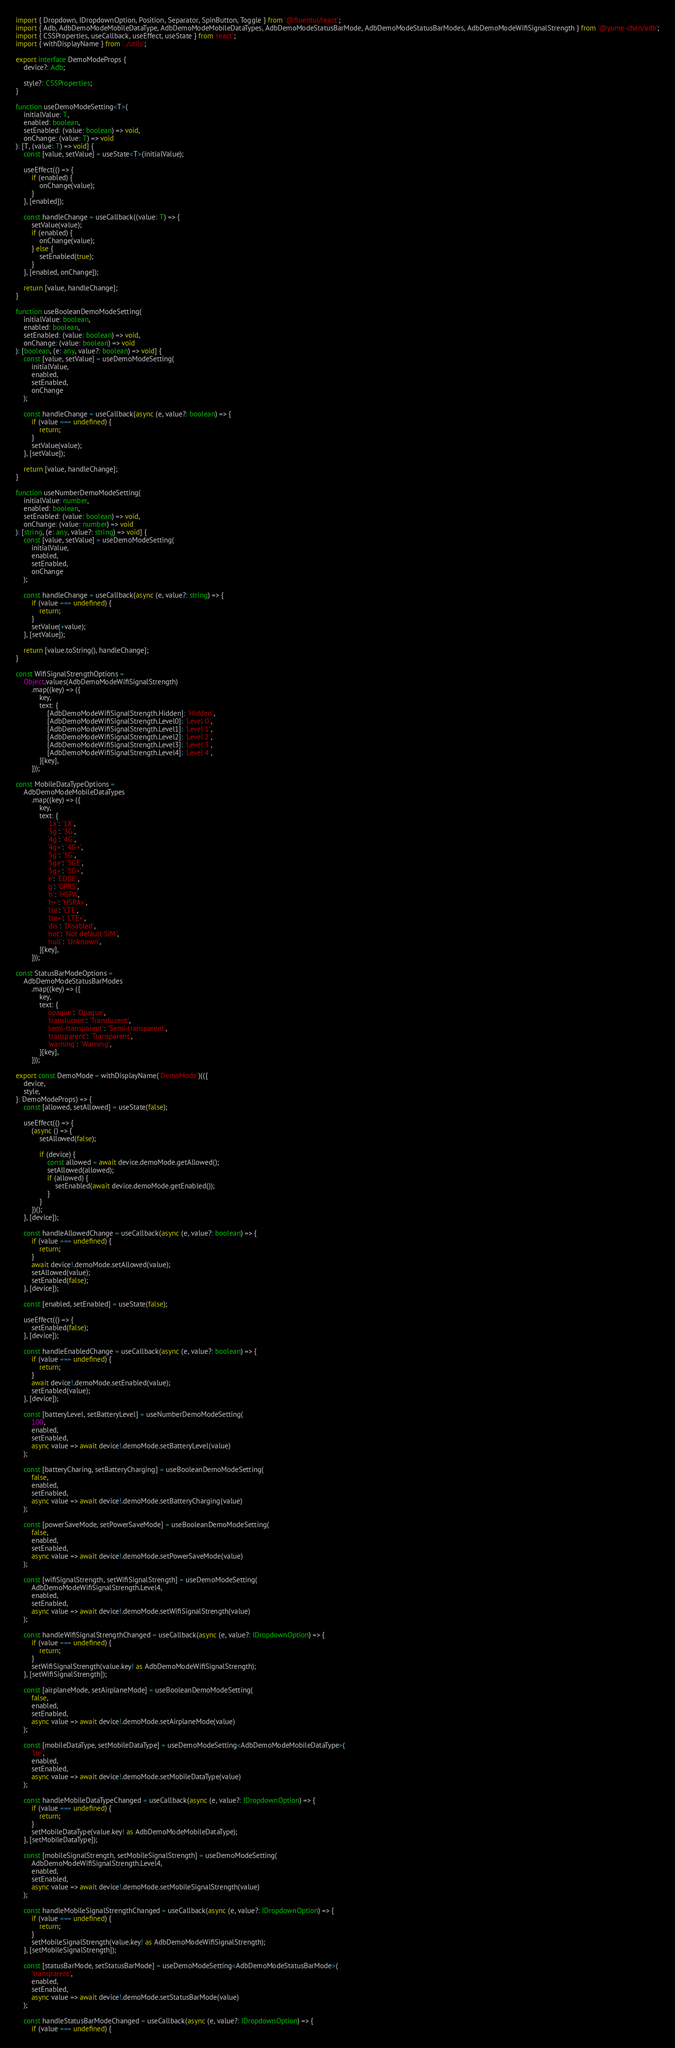<code> <loc_0><loc_0><loc_500><loc_500><_TypeScript_>import { Dropdown, IDropdownOption, Position, Separator, SpinButton, Toggle } from '@fluentui/react';
import { Adb, AdbDemoModeMobileDataType, AdbDemoModeMobileDataTypes, AdbDemoModeStatusBarMode, AdbDemoModeStatusBarModes, AdbDemoModeWifiSignalStrength } from '@yume-chan/adb';
import { CSSProperties, useCallback, useEffect, useState } from 'react';
import { withDisplayName } from '../utils';

export interface DemoModeProps {
    device?: Adb;

    style?: CSSProperties;
}

function useDemoModeSetting<T>(
    initialValue: T,
    enabled: boolean,
    setEnabled: (value: boolean) => void,
    onChange: (value: T) => void
): [T, (value: T) => void] {
    const [value, setValue] = useState<T>(initialValue);

    useEffect(() => {
        if (enabled) {
            onChange(value);
        }
    }, [enabled]);

    const handleChange = useCallback((value: T) => {
        setValue(value);
        if (enabled) {
            onChange(value);
        } else {
            setEnabled(true);
        }
    }, [enabled, onChange]);

    return [value, handleChange];
}

function useBooleanDemoModeSetting(
    initialValue: boolean,
    enabled: boolean,
    setEnabled: (value: boolean) => void,
    onChange: (value: boolean) => void
): [boolean, (e: any, value?: boolean) => void] {
    const [value, setValue] = useDemoModeSetting(
        initialValue,
        enabled,
        setEnabled,
        onChange
    );

    const handleChange = useCallback(async (e, value?: boolean) => {
        if (value === undefined) {
            return;
        }
        setValue(value);
    }, [setValue]);

    return [value, handleChange];
}

function useNumberDemoModeSetting(
    initialValue: number,
    enabled: boolean,
    setEnabled: (value: boolean) => void,
    onChange: (value: number) => void
): [string, (e: any, value?: string) => void] {
    const [value, setValue] = useDemoModeSetting(
        initialValue,
        enabled,
        setEnabled,
        onChange
    );

    const handleChange = useCallback(async (e, value?: string) => {
        if (value === undefined) {
            return;
        }
        setValue(+value);
    }, [setValue]);

    return [value.toString(), handleChange];
}

const WifiSignalStrengthOptions =
    Object.values(AdbDemoModeWifiSignalStrength)
        .map((key) => ({
            key,
            text: {
                [AdbDemoModeWifiSignalStrength.Hidden]: 'Hidden',
                [AdbDemoModeWifiSignalStrength.Level0]: 'Level 0',
                [AdbDemoModeWifiSignalStrength.Level1]: 'Level 1',
                [AdbDemoModeWifiSignalStrength.Level2]: 'Level 2',
                [AdbDemoModeWifiSignalStrength.Level3]: 'Level 3',
                [AdbDemoModeWifiSignalStrength.Level4]: 'Level 4',
            }[key],
        }));

const MobileDataTypeOptions =
    AdbDemoModeMobileDataTypes
        .map((key) => ({
            key,
            text: {
                '1x': '1X',
                '3g': '3G',
                '4g': '4G',
                '4g+': '4G+',
                '5g': '5G',
                '5ge': '5GE',
                '5g+': '5G+',
                'e': 'EDGE',
                'g': 'GPRS',
                'h': 'HSPA',
                'h+': 'HSPA+',
                'lte': 'LTE',
                'lte+': 'LTE+',
                'dis': 'Disabled',
                'not': 'Not default SIM',
                'null': 'Unknown',
            }[key],
        }));

const StatusBarModeOptions =
    AdbDemoModeStatusBarModes
        .map((key) => ({
            key,
            text: {
                'opaque': 'Opaque',
                'translucent': 'Translucent',
                'semi-transparent': 'Semi-transparent',
                'transparent': 'Transparent',
                'warning': 'Warning',
            }[key],
        }));

export const DemoMode = withDisplayName('DemoMode')(({
    device,
    style,
}: DemoModeProps) => {
    const [allowed, setAllowed] = useState(false);

    useEffect(() => {
        (async () => {
            setAllowed(false);

            if (device) {
                const allowed = await device.demoMode.getAllowed();
                setAllowed(allowed);
                if (allowed) {
                    setEnabled(await device.demoMode.getEnabled());
                }
            }
        })();
    }, [device]);

    const handleAllowedChange = useCallback(async (e, value?: boolean) => {
        if (value === undefined) {
            return;
        }
        await device!.demoMode.setAllowed(value);
        setAllowed(value);
        setEnabled(false);
    }, [device]);

    const [enabled, setEnabled] = useState(false);

    useEffect(() => {
        setEnabled(false);
    }, [device]);

    const handleEnabledChange = useCallback(async (e, value?: boolean) => {
        if (value === undefined) {
            return;
        }
        await device!.demoMode.setEnabled(value);
        setEnabled(value);
    }, [device]);

    const [batteryLevel, setBatteryLevel] = useNumberDemoModeSetting(
        100,
        enabled,
        setEnabled,
        async value => await device!.demoMode.setBatteryLevel(value)
    );

    const [batteryCharing, setBatteryCharging] = useBooleanDemoModeSetting(
        false,
        enabled,
        setEnabled,
        async value => await device!.demoMode.setBatteryCharging(value)
    );

    const [powerSaveMode, setPowerSaveMode] = useBooleanDemoModeSetting(
        false,
        enabled,
        setEnabled,
        async value => await device!.demoMode.setPowerSaveMode(value)
    );

    const [wifiSignalStrength, setWifiSignalStrength] = useDemoModeSetting(
        AdbDemoModeWifiSignalStrength.Level4,
        enabled,
        setEnabled,
        async value => await device!.demoMode.setWifiSignalStrength(value)
    );

    const handleWifiSignalStrengthChanged = useCallback(async (e, value?: IDropdownOption) => {
        if (value === undefined) {
            return;
        }
        setWifiSignalStrength(value.key! as AdbDemoModeWifiSignalStrength);
    }, [setWifiSignalStrength]);

    const [airplaneMode, setAirplaneMode] = useBooleanDemoModeSetting(
        false,
        enabled,
        setEnabled,
        async value => await device!.demoMode.setAirplaneMode(value)
    );

    const [mobileDataType, setMobileDataType] = useDemoModeSetting<AdbDemoModeMobileDataType>(
        'lte',
        enabled,
        setEnabled,
        async value => await device!.demoMode.setMobileDataType(value)
    );

    const handleMobileDataTypeChanged = useCallback(async (e, value?: IDropdownOption) => {
        if (value === undefined) {
            return;
        }
        setMobileDataType(value.key! as AdbDemoModeMobileDataType);
    }, [setMobileDataType]);

    const [mobileSignalStrength, setMobileSignalStrength] = useDemoModeSetting(
        AdbDemoModeWifiSignalStrength.Level4,
        enabled,
        setEnabled,
        async value => await device!.demoMode.setMobileSignalStrength(value)
    );

    const handleMobileSignalStrengthChanged = useCallback(async (e, value?: IDropdownOption) => {
        if (value === undefined) {
            return;
        }
        setMobileSignalStrength(value.key! as AdbDemoModeWifiSignalStrength);
    }, [setMobileSignalStrength]);

    const [statusBarMode, setStatusBarMode] = useDemoModeSetting<AdbDemoModeStatusBarMode>(
        'transparent',
        enabled,
        setEnabled,
        async value => await device!.demoMode.setStatusBarMode(value)
    );

    const handleStatusBarModeChanged = useCallback(async (e, value?: IDropdownOption) => {
        if (value === undefined) {</code> 